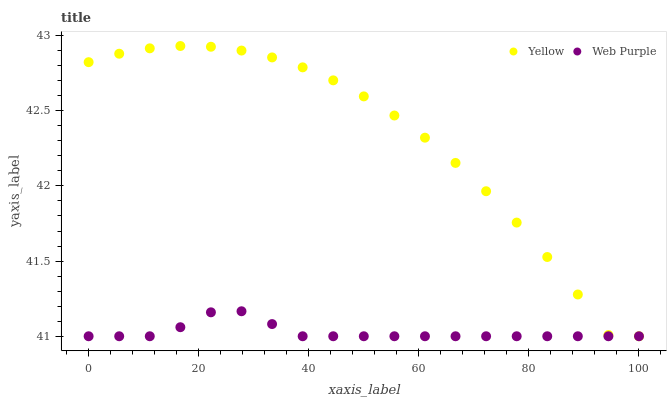Does Web Purple have the minimum area under the curve?
Answer yes or no. Yes. Does Yellow have the maximum area under the curve?
Answer yes or no. Yes. Does Yellow have the minimum area under the curve?
Answer yes or no. No. Is Web Purple the smoothest?
Answer yes or no. Yes. Is Yellow the roughest?
Answer yes or no. Yes. Is Yellow the smoothest?
Answer yes or no. No. Does Web Purple have the lowest value?
Answer yes or no. Yes. Does Yellow have the highest value?
Answer yes or no. Yes. Does Web Purple intersect Yellow?
Answer yes or no. Yes. Is Web Purple less than Yellow?
Answer yes or no. No. Is Web Purple greater than Yellow?
Answer yes or no. No. 